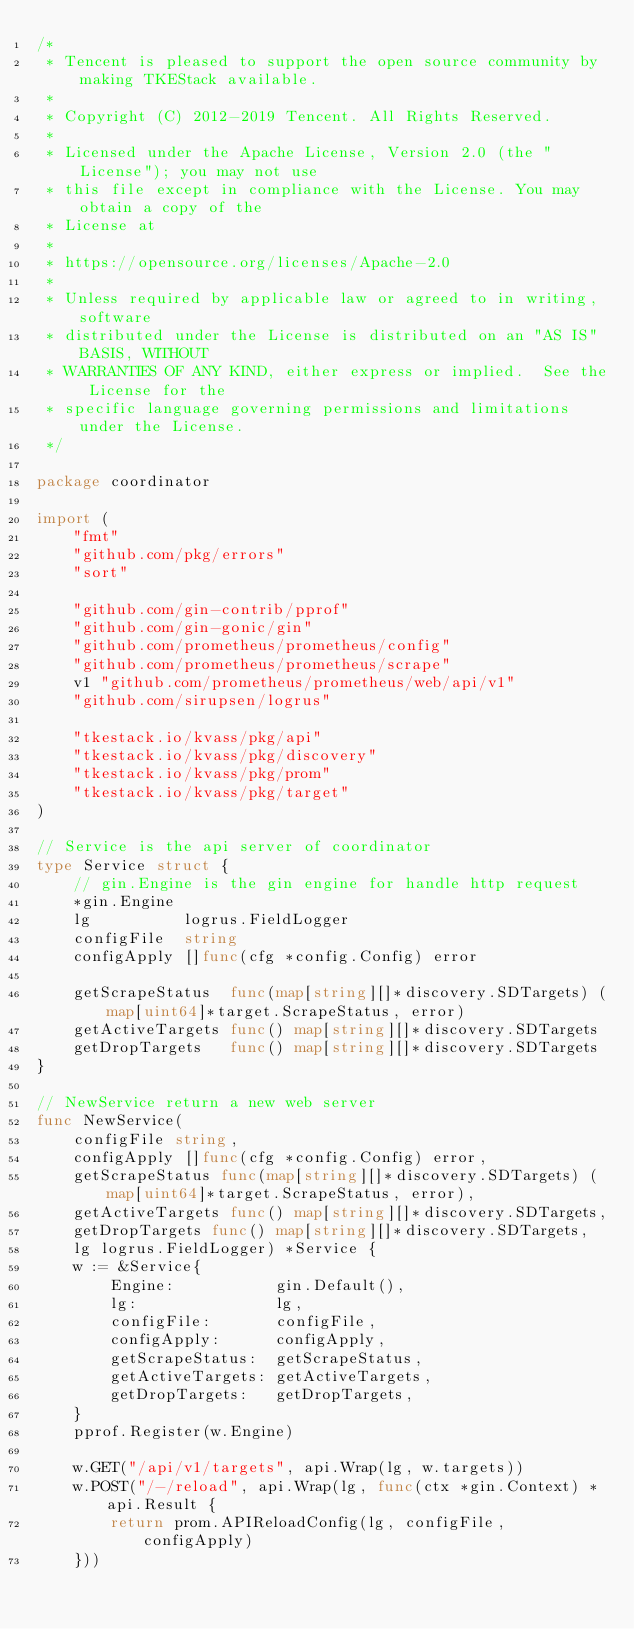<code> <loc_0><loc_0><loc_500><loc_500><_Go_>/*
 * Tencent is pleased to support the open source community by making TKEStack available.
 *
 * Copyright (C) 2012-2019 Tencent. All Rights Reserved.
 *
 * Licensed under the Apache License, Version 2.0 (the "License"); you may not use
 * this file except in compliance with the License. You may obtain a copy of the
 * License at
 *
 * https://opensource.org/licenses/Apache-2.0
 *
 * Unless required by applicable law or agreed to in writing, software
 * distributed under the License is distributed on an "AS IS" BASIS, WITHOUT
 * WARRANTIES OF ANY KIND, either express or implied.  See the License for the
 * specific language governing permissions and limitations under the License.
 */

package coordinator

import (
	"fmt"
	"github.com/pkg/errors"
	"sort"

	"github.com/gin-contrib/pprof"
	"github.com/gin-gonic/gin"
	"github.com/prometheus/prometheus/config"
	"github.com/prometheus/prometheus/scrape"
	v1 "github.com/prometheus/prometheus/web/api/v1"
	"github.com/sirupsen/logrus"

	"tkestack.io/kvass/pkg/api"
	"tkestack.io/kvass/pkg/discovery"
	"tkestack.io/kvass/pkg/prom"
	"tkestack.io/kvass/pkg/target"
)

// Service is the api server of coordinator
type Service struct {
	// gin.Engine is the gin engine for handle http request
	*gin.Engine
	lg          logrus.FieldLogger
	configFile  string
	configApply []func(cfg *config.Config) error

	getScrapeStatus  func(map[string][]*discovery.SDTargets) (map[uint64]*target.ScrapeStatus, error)
	getActiveTargets func() map[string][]*discovery.SDTargets
	getDropTargets   func() map[string][]*discovery.SDTargets
}

// NewService return a new web server
func NewService(
	configFile string,
	configApply []func(cfg *config.Config) error,
	getScrapeStatus func(map[string][]*discovery.SDTargets) (map[uint64]*target.ScrapeStatus, error),
	getActiveTargets func() map[string][]*discovery.SDTargets,
	getDropTargets func() map[string][]*discovery.SDTargets,
	lg logrus.FieldLogger) *Service {
	w := &Service{
		Engine:           gin.Default(),
		lg:               lg,
		configFile:       configFile,
		configApply:      configApply,
		getScrapeStatus:  getScrapeStatus,
		getActiveTargets: getActiveTargets,
		getDropTargets:   getDropTargets,
	}
	pprof.Register(w.Engine)

	w.GET("/api/v1/targets", api.Wrap(lg, w.targets))
	w.POST("/-/reload", api.Wrap(lg, func(ctx *gin.Context) *api.Result {
		return prom.APIReloadConfig(lg, configFile, configApply)
	}))</code> 